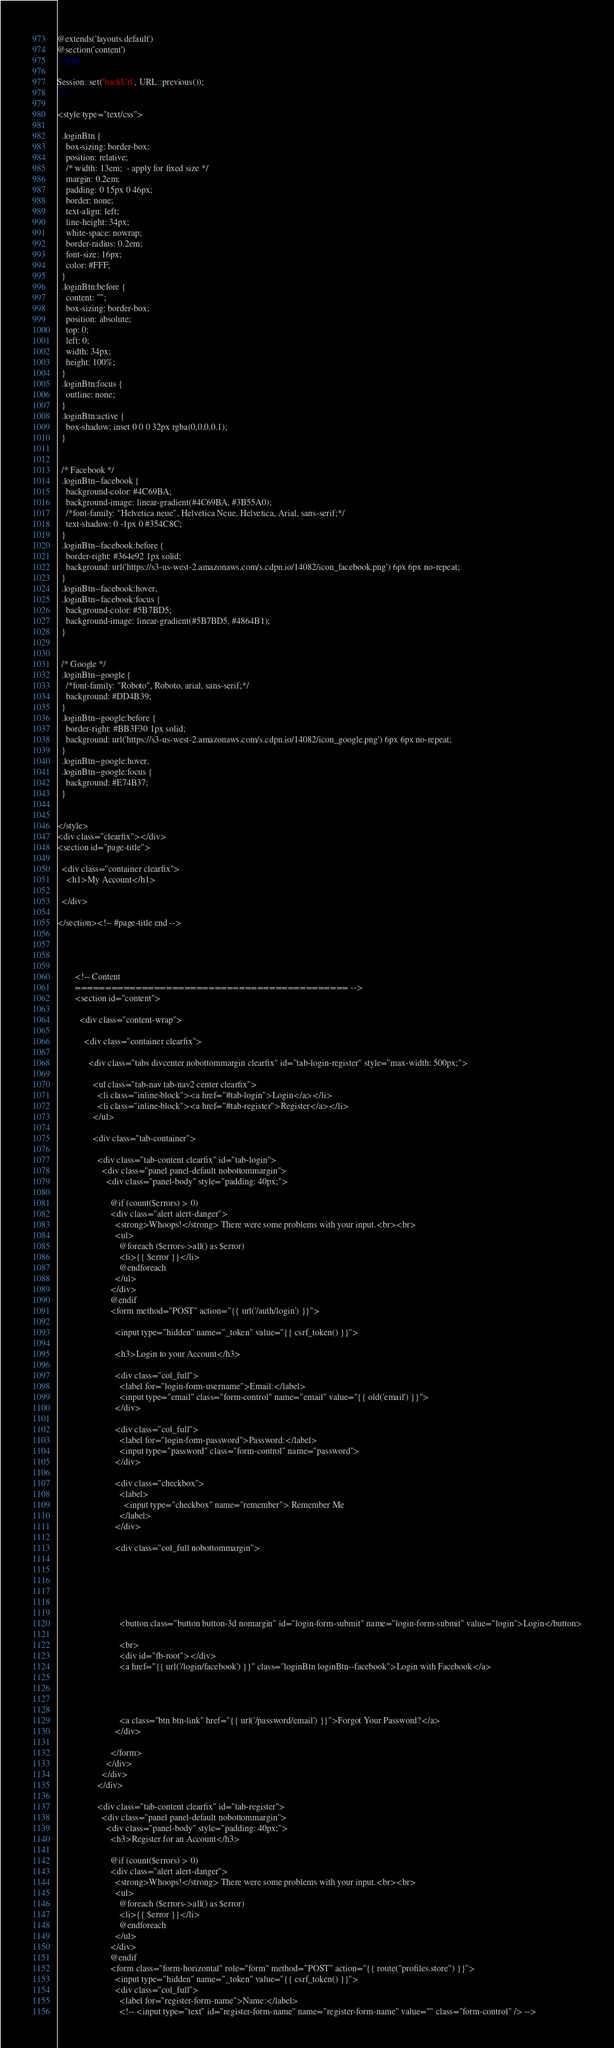<code> <loc_0><loc_0><loc_500><loc_500><_PHP_>@extends('layouts.default')
@section('content')
<?php

Session::set('backUrl', URL::previous());
?>

<style type="text/css">

  .loginBtn {
    box-sizing: border-box;
    position: relative;
    /* width: 13em;  - apply for fixed size */
    margin: 0.2em;
    padding: 0 15px 0 46px;
    border: none;
    text-align: left;
    line-height: 34px;
    white-space: nowrap;
    border-radius: 0.2em;
    font-size: 16px;
    color: #FFF;
  }
  .loginBtn:before {
    content: "";
    box-sizing: border-box;
    position: absolute;
    top: 0;
    left: 0;
    width: 34px;
    height: 100%;
  }
  .loginBtn:focus {
    outline: none;
  }
  .loginBtn:active {
    box-shadow: inset 0 0 0 32px rgba(0,0,0,0.1);
  }


  /* Facebook */
  .loginBtn--facebook {
    background-color: #4C69BA;
    background-image: linear-gradient(#4C69BA, #3B55A0);
    /*font-family: "Helvetica neue", Helvetica Neue, Helvetica, Arial, sans-serif;*/
    text-shadow: 0 -1px 0 #354C8C;
  }
  .loginBtn--facebook:before {
    border-right: #364e92 1px solid;
    background: url('https://s3-us-west-2.amazonaws.com/s.cdpn.io/14082/icon_facebook.png') 6px 6px no-repeat;
  }
  .loginBtn--facebook:hover,
  .loginBtn--facebook:focus {
    background-color: #5B7BD5;
    background-image: linear-gradient(#5B7BD5, #4864B1);
  }


  /* Google */
  .loginBtn--google {
    /*font-family: "Roboto", Roboto, arial, sans-serif;*/
    background: #DD4B39;
  }
  .loginBtn--google:before {
    border-right: #BB3F30 1px solid;
    background: url('https://s3-us-west-2.amazonaws.com/s.cdpn.io/14082/icon_google.png') 6px 6px no-repeat;
  }
  .loginBtn--google:hover,
  .loginBtn--google:focus {
    background: #E74B37;
  }


</style>
<div class="clearfix"></div>
<section id="page-title">

  <div class="container clearfix">
    <h1>My Account</h1>

  </div>

</section><!-- #page-title end -->




        <!-- Content
        ============================================= -->
        <section id="content">

          <div class="content-wrap">

            <div class="container clearfix">

              <div class="tabs divcenter nobottommargin clearfix" id="tab-login-register" style="max-width: 500px;">

                <ul class="tab-nav tab-nav2 center clearfix">
                  <li class="inline-block"><a href="#tab-login">Login</a></li>
                  <li class="inline-block"><a href="#tab-register">Register</a></li>
                </ul>

                <div class="tab-container">

                  <div class="tab-content clearfix" id="tab-login">
                    <div class="panel panel-default nobottommargin">
                      <div class="panel-body" style="padding: 40px;">

                        @if (count($errors) > 0)
                        <div class="alert alert-danger">
                          <strong>Whoops!</strong> There were some problems with your input.<br><br>
                          <ul>
                            @foreach ($errors->all() as $error)
                            <li>{{ $error }}</li>
                            @endforeach
                          </ul>
                        </div>
                        @endif
                        <form method="POST" action="{{ url('/auth/login') }}">
                         
                          <input type="hidden" name="_token" value="{{ csrf_token() }}">

                          <h3>Login to your Account</h3>

                          <div class="col_full">
                            <label for="login-form-username">Email:</label>
                            <input type="email" class="form-control" name="email" value="{{ old('email') }}">
                          </div>

                          <div class="col_full">
                            <label for="login-form-password">Password:</label>
                            <input type="password" class="form-control" name="password">
                          </div>

                          <div class="checkbox">
                            <label>
                              <input type="checkbox" name="remember"> Remember Me
                            </label>
                          </div>

                          <div class="col_full nobottommargin">




                            

                            <button class="button button-3d nomargin" id="login-form-submit" name="login-form-submit" value="login">Login</button>

                            <br>
                            <div id="fb-root"></div>
                            <a href="{{ url('/login/facebook') }}" class="loginBtn loginBtn--facebook">Login with Facebook</a>
                           


                            
                            <a class="btn btn-link" href="{{ url('/password/email') }}">Forgot Your Password?</a>
                          </div>

                        </form>
                      </div>
                    </div>
                  </div>

                  <div class="tab-content clearfix" id="tab-register">
                    <div class="panel panel-default nobottommargin">
                      <div class="panel-body" style="padding: 40px;">
                        <h3>Register for an Account</h3>

                        @if (count($errors) > 0)
                        <div class="alert alert-danger">
                          <strong>Whoops!</strong> There were some problems with your input.<br><br>
                          <ul>
                            @foreach ($errors->all() as $error)
                            <li>{{ $error }}</li>
                            @endforeach
                          </ul>
                        </div>
                        @endif
                        <form class="form-horizontal" role="form" method="POST" action="{{ route("profiles.store") }}">
                          <input type="hidden" name="_token" value="{{ csrf_token() }}">    
                          <div class="col_full">
                            <label for="register-form-name">Name:</label>
                            <!-- <input type="text" id="register-form-name" name="register-form-name" value="" class="form-control" /> --></code> 